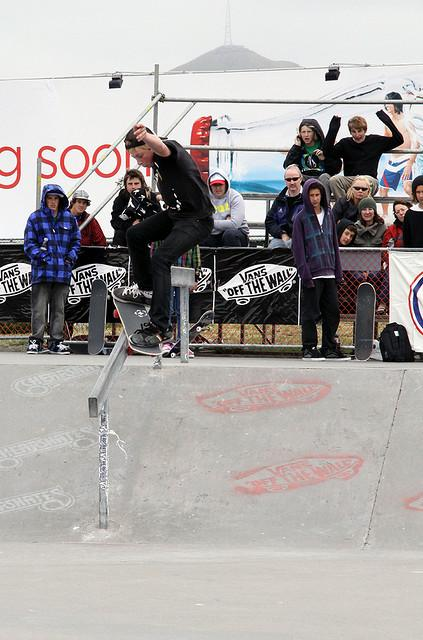What is he doing hanging from the board?

Choices:
A) jumping
B) falling
C) balancing
D) bouncing balancing 